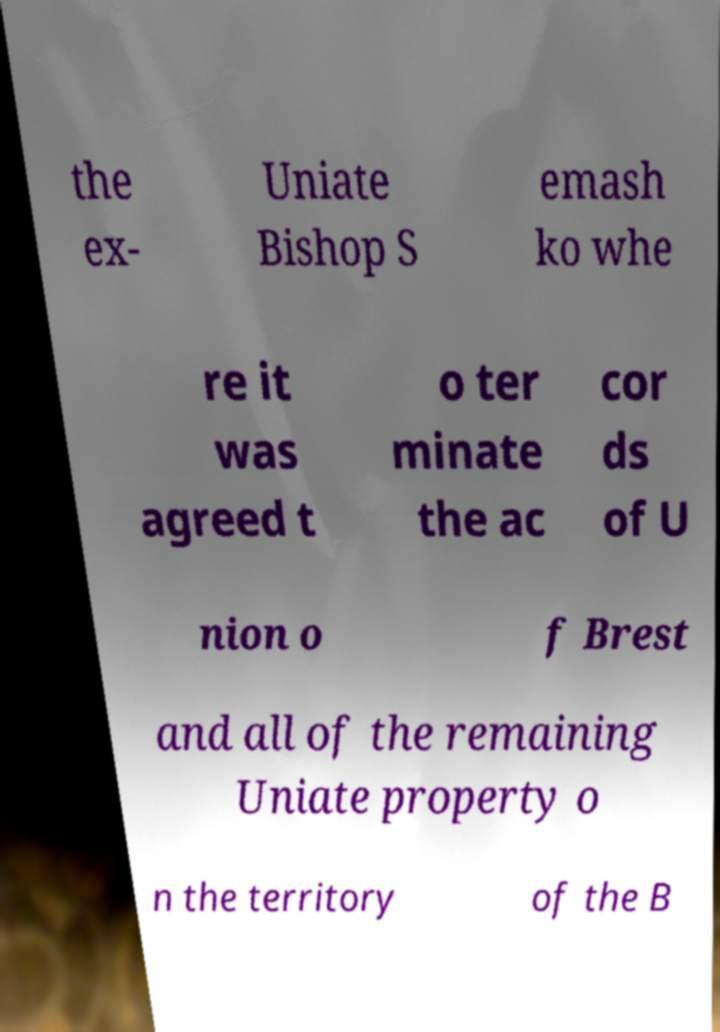There's text embedded in this image that I need extracted. Can you transcribe it verbatim? the ex- Uniate Bishop S emash ko whe re it was agreed t o ter minate the ac cor ds of U nion o f Brest and all of the remaining Uniate property o n the territory of the B 